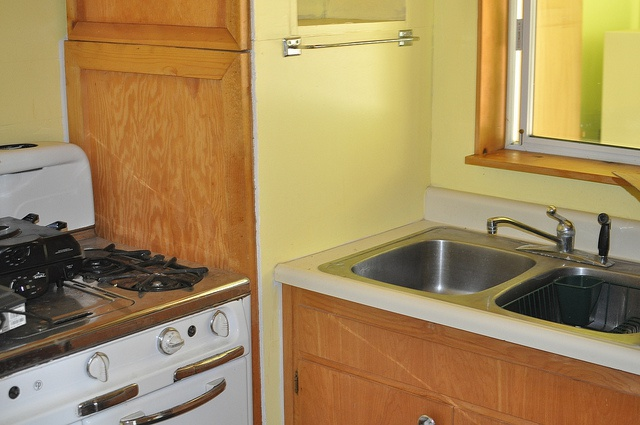Describe the objects in this image and their specific colors. I can see oven in tan, darkgray, black, gray, and lightgray tones and sink in tan, black, gray, and olive tones in this image. 